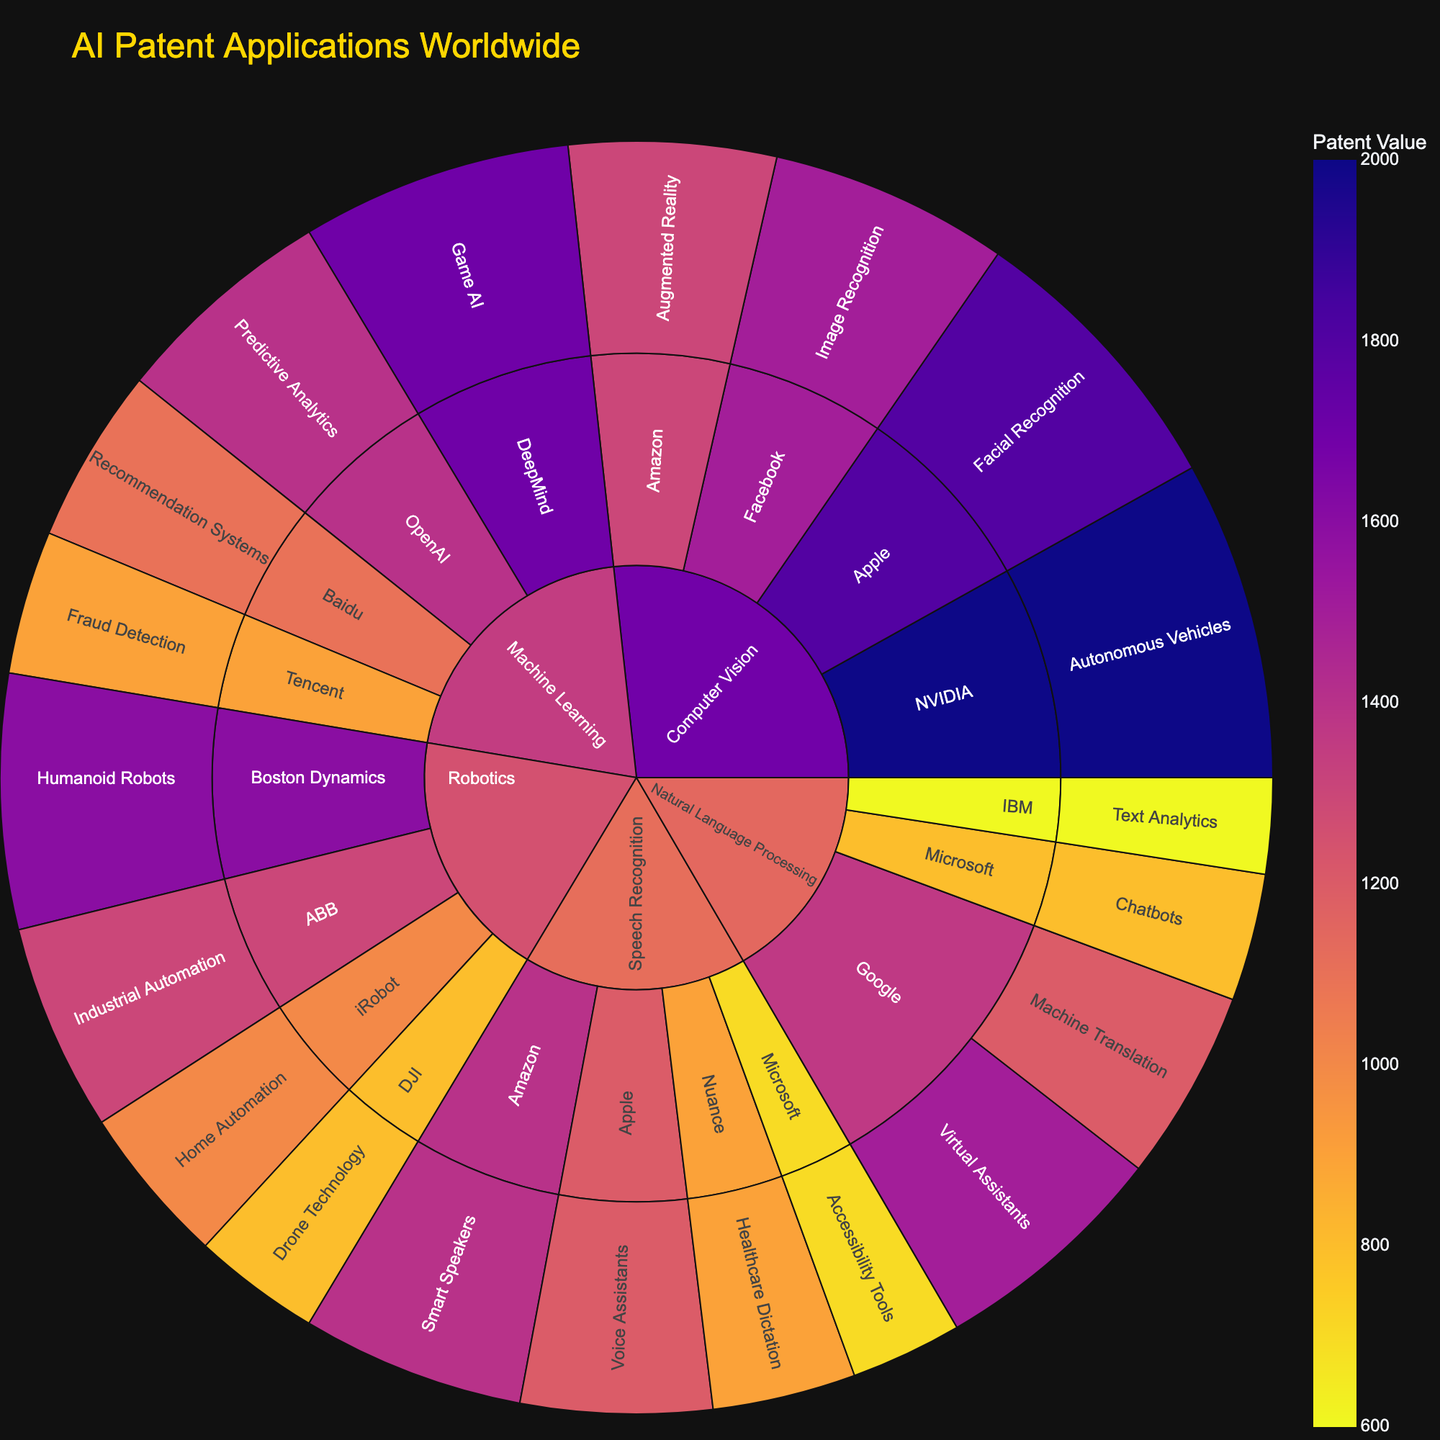How many patent applications does Google have in Natural Language Processing? Locate the "Google" organization within the "Natural Language Processing" technology segment; sum the values for Google's applications: 1500 (Virtual Assistants) + 1200 (Machine Translation).
Answer: 2700 What is the most common application type for Computer Vision technology? Identify the applications under "Computer Vision" and compare their patent values: Autonomous Vehicles (2000), Facial Recognition (1800), Image Recognition (1500), and Augmented Reality (1300). The one with the highest value is the most common.
Answer: Autonomous Vehicles Which organization has the highest number of patent applications in Robotics? Identify the organizations under "Robotics" and compare their values: Boston Dynamics (1600), ABB (1300), iRobot (1000), DJI (800). The highest value indicates the organization with the most patents.
Answer: Boston Dynamics How does the total number of patent applications in Machine Learning compare to those in Speech Recognition? Sum the values for all organizations in "Machine Learning" (DeepMind: 1700, OpenAI: 1400, Baidu: 1100, Tencent: 900) and in "Speech Recognition" (Amazon: 1400, Apple: 1200, Nuance: 900, Microsoft: 700). Compute the totals: Machine Learning = 5100, Speech Recognition = 4200. Compare these totals.
Answer: Machine Learning has more patents What is the title of the sunburst plot? Find the title displayed at the top of the plot.
Answer: AI Patent Applications Worldwide Which application has the least number of patent applications in the data? Navigate through all segments to find the application with the lowest value. Comparisons reveal that accessibility tools under Speech Recognition by Microsoft (700) is the smallest.
Answer: Accessibility Tools How many patent applications does Nuance have in Speech Recognition? Locate "Nuance" under "Speech Recognition" and find the value next to "Healthcare Dictation."
Answer: 900 What is the smallest difference between the number of patent applications for any two organizations within Computer Vision? Compare the patent values of organizations within "Computer Vision": NVIDIA (2000), Apple (1800), Facebook (1500), Amazon (1300). Calculate differences and identify the smallest one, which is between Apple and Facebook: 1800 - 1500.
Answer: 300 Which technology type encompasses the widest range of applications, judging by the number of distinct applications? Identify and count the distinct applications within each technology type: Natural Language Processing (4), Computer Vision (4), Machine Learning (4), Robotics (4), Speech Recognition (4). All types have the same number.
Answer: All technology types have 4 applications 